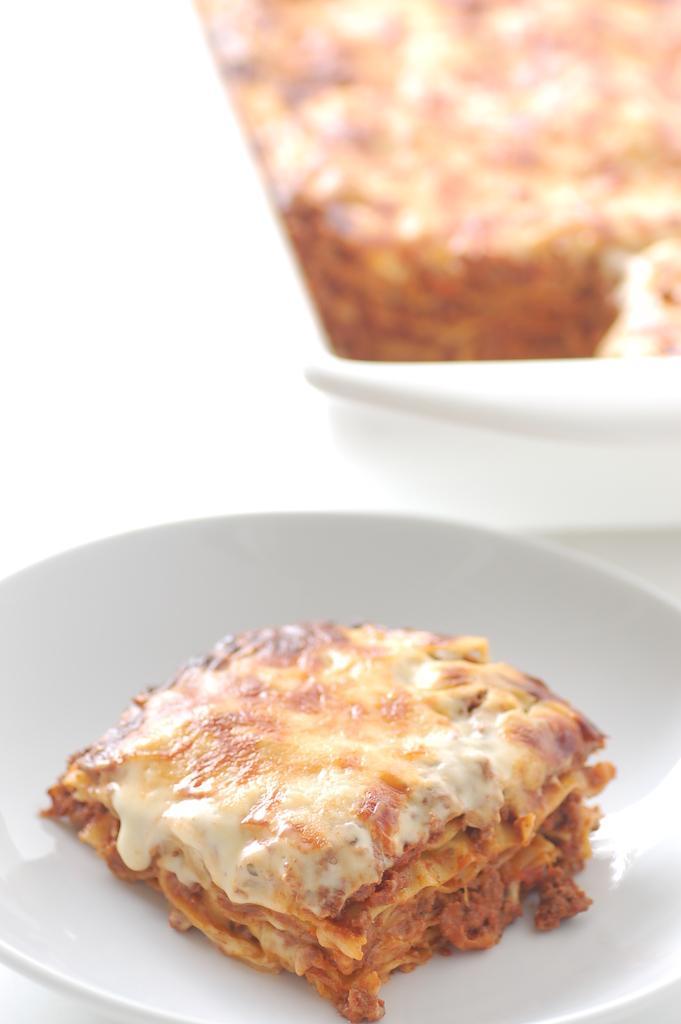Please provide a concise description of this image. In the image we can see a plate, in the plate there is food. 